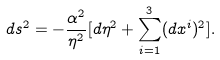<formula> <loc_0><loc_0><loc_500><loc_500>d s ^ { 2 } = - \frac { \alpha ^ { 2 } } { \eta ^ { 2 } } [ d \eta ^ { 2 } + \sum _ { i = 1 } ^ { 3 } ( d x ^ { i } ) ^ { 2 } ] .</formula> 